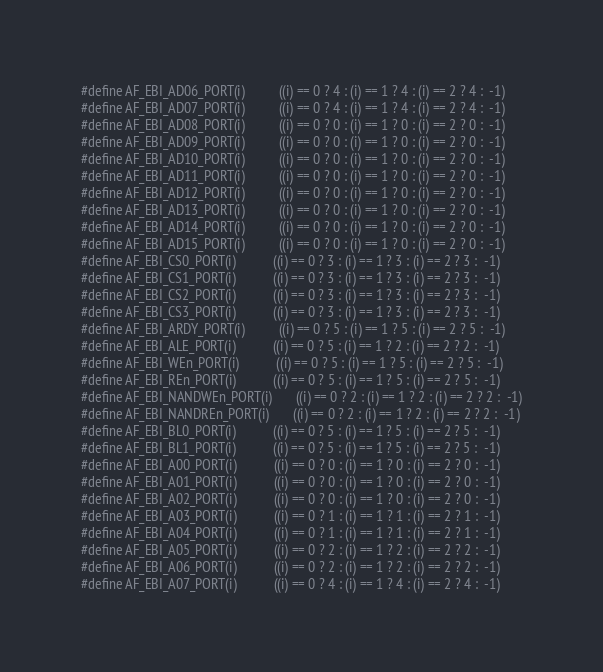Convert code to text. <code><loc_0><loc_0><loc_500><loc_500><_C_>#define AF_EBI_AD06_PORT(i)          ((i) == 0 ? 4 : (i) == 1 ? 4 : (i) == 2 ? 4 :  -1)
#define AF_EBI_AD07_PORT(i)          ((i) == 0 ? 4 : (i) == 1 ? 4 : (i) == 2 ? 4 :  -1)
#define AF_EBI_AD08_PORT(i)          ((i) == 0 ? 0 : (i) == 1 ? 0 : (i) == 2 ? 0 :  -1)
#define AF_EBI_AD09_PORT(i)          ((i) == 0 ? 0 : (i) == 1 ? 0 : (i) == 2 ? 0 :  -1)
#define AF_EBI_AD10_PORT(i)          ((i) == 0 ? 0 : (i) == 1 ? 0 : (i) == 2 ? 0 :  -1)
#define AF_EBI_AD11_PORT(i)          ((i) == 0 ? 0 : (i) == 1 ? 0 : (i) == 2 ? 0 :  -1)
#define AF_EBI_AD12_PORT(i)          ((i) == 0 ? 0 : (i) == 1 ? 0 : (i) == 2 ? 0 :  -1)
#define AF_EBI_AD13_PORT(i)          ((i) == 0 ? 0 : (i) == 1 ? 0 : (i) == 2 ? 0 :  -1)
#define AF_EBI_AD14_PORT(i)          ((i) == 0 ? 0 : (i) == 1 ? 0 : (i) == 2 ? 0 :  -1)
#define AF_EBI_AD15_PORT(i)          ((i) == 0 ? 0 : (i) == 1 ? 0 : (i) == 2 ? 0 :  -1)
#define AF_EBI_CS0_PORT(i)           ((i) == 0 ? 3 : (i) == 1 ? 3 : (i) == 2 ? 3 :  -1)
#define AF_EBI_CS1_PORT(i)           ((i) == 0 ? 3 : (i) == 1 ? 3 : (i) == 2 ? 3 :  -1)
#define AF_EBI_CS2_PORT(i)           ((i) == 0 ? 3 : (i) == 1 ? 3 : (i) == 2 ? 3 :  -1)
#define AF_EBI_CS3_PORT(i)           ((i) == 0 ? 3 : (i) == 1 ? 3 : (i) == 2 ? 3 :  -1)
#define AF_EBI_ARDY_PORT(i)          ((i) == 0 ? 5 : (i) == 1 ? 5 : (i) == 2 ? 5 :  -1)
#define AF_EBI_ALE_PORT(i)           ((i) == 0 ? 5 : (i) == 1 ? 2 : (i) == 2 ? 2 :  -1)
#define AF_EBI_WEn_PORT(i)           ((i) == 0 ? 5 : (i) == 1 ? 5 : (i) == 2 ? 5 :  -1)
#define AF_EBI_REn_PORT(i)           ((i) == 0 ? 5 : (i) == 1 ? 5 : (i) == 2 ? 5 :  -1)
#define AF_EBI_NANDWEn_PORT(i)       ((i) == 0 ? 2 : (i) == 1 ? 2 : (i) == 2 ? 2 :  -1)
#define AF_EBI_NANDREn_PORT(i)       ((i) == 0 ? 2 : (i) == 1 ? 2 : (i) == 2 ? 2 :  -1)
#define AF_EBI_BL0_PORT(i)           ((i) == 0 ? 5 : (i) == 1 ? 5 : (i) == 2 ? 5 :  -1)
#define AF_EBI_BL1_PORT(i)           ((i) == 0 ? 5 : (i) == 1 ? 5 : (i) == 2 ? 5 :  -1)
#define AF_EBI_A00_PORT(i)           ((i) == 0 ? 0 : (i) == 1 ? 0 : (i) == 2 ? 0 :  -1)
#define AF_EBI_A01_PORT(i)           ((i) == 0 ? 0 : (i) == 1 ? 0 : (i) == 2 ? 0 :  -1)
#define AF_EBI_A02_PORT(i)           ((i) == 0 ? 0 : (i) == 1 ? 0 : (i) == 2 ? 0 :  -1)
#define AF_EBI_A03_PORT(i)           ((i) == 0 ? 1 : (i) == 1 ? 1 : (i) == 2 ? 1 :  -1)
#define AF_EBI_A04_PORT(i)           ((i) == 0 ? 1 : (i) == 1 ? 1 : (i) == 2 ? 1 :  -1)
#define AF_EBI_A05_PORT(i)           ((i) == 0 ? 2 : (i) == 1 ? 2 : (i) == 2 ? 2 :  -1)
#define AF_EBI_A06_PORT(i)           ((i) == 0 ? 2 : (i) == 1 ? 2 : (i) == 2 ? 2 :  -1)
#define AF_EBI_A07_PORT(i)           ((i) == 0 ? 4 : (i) == 1 ? 4 : (i) == 2 ? 4 :  -1)</code> 